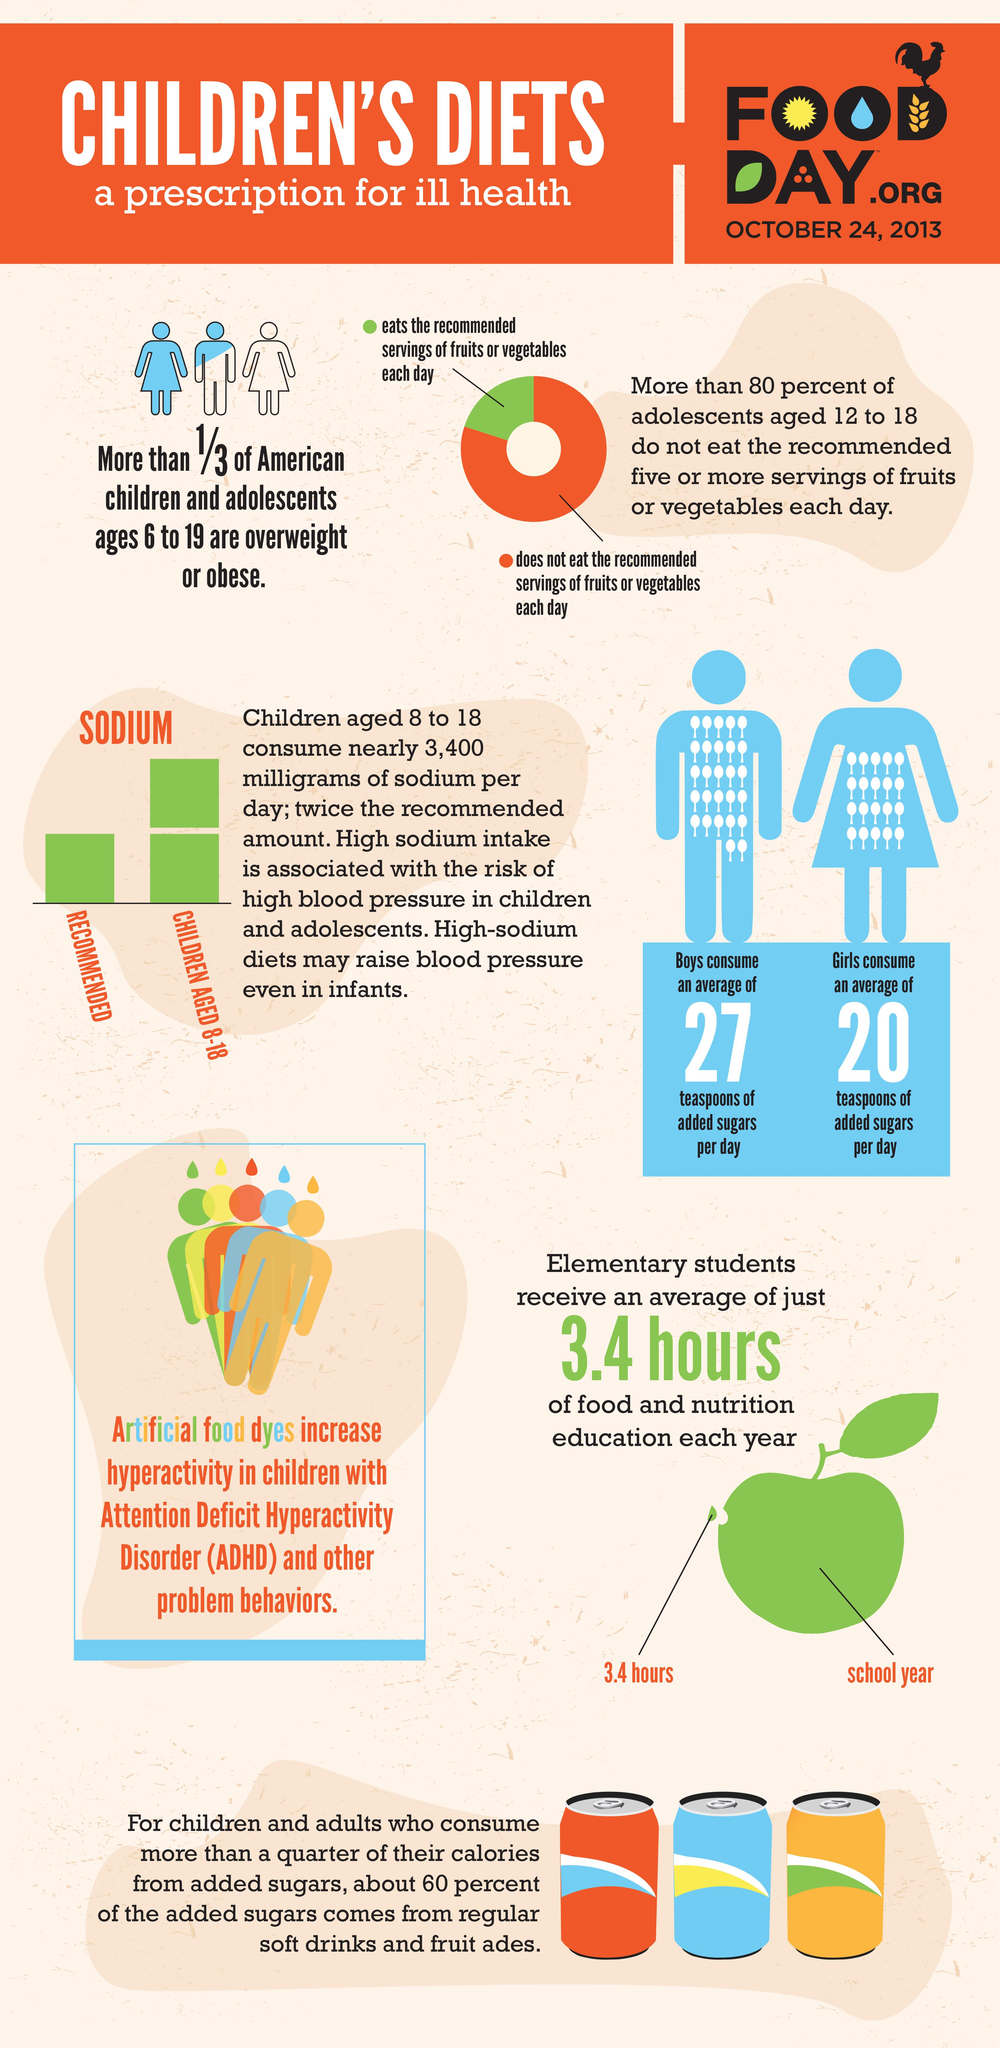Point out several critical features in this image. According to recent data, approximately 6.67% of children in America between the ages of 6 and 19 are not obese. Soft drinks and fruitades are the most common sources of added sugar. The average daily sugar consumption of girls is 20 grams. Children who eat fruits and vegetables in abundance every day are assigned a color code of yellow, orange, white, and green. Green is the color given to those children who consume the maximum amount of fruits and vegetables on a daily basis. 